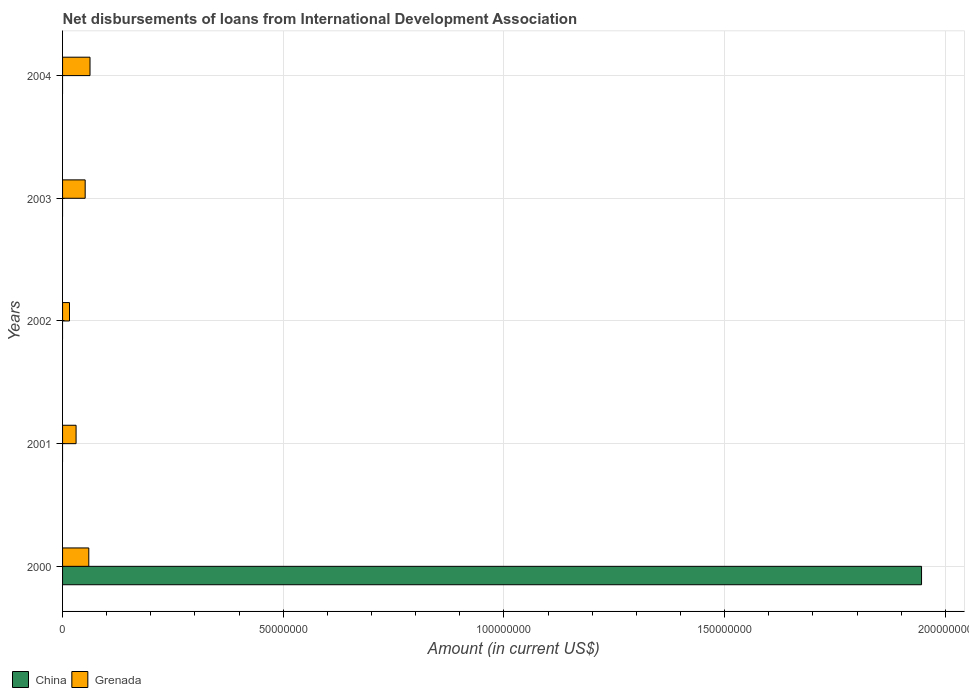Are the number of bars per tick equal to the number of legend labels?
Give a very brief answer. No. Are the number of bars on each tick of the Y-axis equal?
Ensure brevity in your answer.  No. How many bars are there on the 2nd tick from the bottom?
Make the answer very short. 1. What is the label of the 3rd group of bars from the top?
Give a very brief answer. 2002. What is the amount of loans disbursed in China in 2003?
Ensure brevity in your answer.  0. Across all years, what is the maximum amount of loans disbursed in China?
Offer a terse response. 1.95e+08. Across all years, what is the minimum amount of loans disbursed in China?
Give a very brief answer. 0. In which year was the amount of loans disbursed in China maximum?
Ensure brevity in your answer.  2000. What is the total amount of loans disbursed in Grenada in the graph?
Offer a very short reply. 2.19e+07. What is the difference between the amount of loans disbursed in Grenada in 2000 and that in 2002?
Your answer should be very brief. 4.37e+06. What is the difference between the amount of loans disbursed in China in 2000 and the amount of loans disbursed in Grenada in 2001?
Give a very brief answer. 1.92e+08. What is the average amount of loans disbursed in Grenada per year?
Provide a succinct answer. 4.38e+06. In the year 2000, what is the difference between the amount of loans disbursed in Grenada and amount of loans disbursed in China?
Provide a short and direct response. -1.89e+08. What is the ratio of the amount of loans disbursed in Grenada in 2001 to that in 2002?
Offer a very short reply. 1.95. What is the difference between the highest and the second highest amount of loans disbursed in Grenada?
Your response must be concise. 2.77e+05. What is the difference between the highest and the lowest amount of loans disbursed in Grenada?
Your response must be concise. 4.65e+06. In how many years, is the amount of loans disbursed in Grenada greater than the average amount of loans disbursed in Grenada taken over all years?
Make the answer very short. 3. Is the sum of the amount of loans disbursed in Grenada in 2000 and 2004 greater than the maximum amount of loans disbursed in China across all years?
Your answer should be very brief. No. How many bars are there?
Give a very brief answer. 6. What is the difference between two consecutive major ticks on the X-axis?
Provide a succinct answer. 5.00e+07. Does the graph contain any zero values?
Your answer should be compact. Yes. What is the title of the graph?
Your response must be concise. Net disbursements of loans from International Development Association. What is the label or title of the X-axis?
Provide a short and direct response. Amount (in current US$). What is the label or title of the Y-axis?
Your response must be concise. Years. What is the Amount (in current US$) of China in 2000?
Keep it short and to the point. 1.95e+08. What is the Amount (in current US$) in Grenada in 2000?
Provide a succinct answer. 5.94e+06. What is the Amount (in current US$) in Grenada in 2001?
Provide a succinct answer. 3.06e+06. What is the Amount (in current US$) of China in 2002?
Ensure brevity in your answer.  0. What is the Amount (in current US$) of Grenada in 2002?
Your answer should be very brief. 1.57e+06. What is the Amount (in current US$) in Grenada in 2003?
Offer a terse response. 5.12e+06. What is the Amount (in current US$) in China in 2004?
Provide a short and direct response. 0. What is the Amount (in current US$) of Grenada in 2004?
Provide a succinct answer. 6.22e+06. Across all years, what is the maximum Amount (in current US$) in China?
Provide a succinct answer. 1.95e+08. Across all years, what is the maximum Amount (in current US$) in Grenada?
Make the answer very short. 6.22e+06. Across all years, what is the minimum Amount (in current US$) of Grenada?
Keep it short and to the point. 1.57e+06. What is the total Amount (in current US$) of China in the graph?
Make the answer very short. 1.95e+08. What is the total Amount (in current US$) in Grenada in the graph?
Ensure brevity in your answer.  2.19e+07. What is the difference between the Amount (in current US$) of Grenada in 2000 and that in 2001?
Your answer should be very brief. 2.88e+06. What is the difference between the Amount (in current US$) in Grenada in 2000 and that in 2002?
Offer a terse response. 4.37e+06. What is the difference between the Amount (in current US$) of Grenada in 2000 and that in 2003?
Give a very brief answer. 8.20e+05. What is the difference between the Amount (in current US$) in Grenada in 2000 and that in 2004?
Give a very brief answer. -2.77e+05. What is the difference between the Amount (in current US$) in Grenada in 2001 and that in 2002?
Your answer should be compact. 1.49e+06. What is the difference between the Amount (in current US$) in Grenada in 2001 and that in 2003?
Make the answer very short. -2.06e+06. What is the difference between the Amount (in current US$) in Grenada in 2001 and that in 2004?
Your answer should be very brief. -3.16e+06. What is the difference between the Amount (in current US$) of Grenada in 2002 and that in 2003?
Give a very brief answer. -3.55e+06. What is the difference between the Amount (in current US$) of Grenada in 2002 and that in 2004?
Offer a terse response. -4.65e+06. What is the difference between the Amount (in current US$) in Grenada in 2003 and that in 2004?
Provide a succinct answer. -1.10e+06. What is the difference between the Amount (in current US$) in China in 2000 and the Amount (in current US$) in Grenada in 2001?
Your answer should be compact. 1.92e+08. What is the difference between the Amount (in current US$) of China in 2000 and the Amount (in current US$) of Grenada in 2002?
Provide a short and direct response. 1.93e+08. What is the difference between the Amount (in current US$) in China in 2000 and the Amount (in current US$) in Grenada in 2003?
Your answer should be compact. 1.89e+08. What is the difference between the Amount (in current US$) in China in 2000 and the Amount (in current US$) in Grenada in 2004?
Give a very brief answer. 1.88e+08. What is the average Amount (in current US$) of China per year?
Provide a succinct answer. 3.89e+07. What is the average Amount (in current US$) of Grenada per year?
Your response must be concise. 4.38e+06. In the year 2000, what is the difference between the Amount (in current US$) of China and Amount (in current US$) of Grenada?
Offer a very short reply. 1.89e+08. What is the ratio of the Amount (in current US$) in Grenada in 2000 to that in 2001?
Your response must be concise. 1.94. What is the ratio of the Amount (in current US$) of Grenada in 2000 to that in 2002?
Give a very brief answer. 3.78. What is the ratio of the Amount (in current US$) in Grenada in 2000 to that in 2003?
Offer a terse response. 1.16. What is the ratio of the Amount (in current US$) of Grenada in 2000 to that in 2004?
Provide a succinct answer. 0.96. What is the ratio of the Amount (in current US$) in Grenada in 2001 to that in 2002?
Offer a very short reply. 1.95. What is the ratio of the Amount (in current US$) of Grenada in 2001 to that in 2003?
Your answer should be very brief. 0.6. What is the ratio of the Amount (in current US$) of Grenada in 2001 to that in 2004?
Provide a succinct answer. 0.49. What is the ratio of the Amount (in current US$) in Grenada in 2002 to that in 2003?
Make the answer very short. 0.31. What is the ratio of the Amount (in current US$) in Grenada in 2002 to that in 2004?
Offer a terse response. 0.25. What is the ratio of the Amount (in current US$) in Grenada in 2003 to that in 2004?
Offer a very short reply. 0.82. What is the difference between the highest and the second highest Amount (in current US$) in Grenada?
Keep it short and to the point. 2.77e+05. What is the difference between the highest and the lowest Amount (in current US$) in China?
Your answer should be compact. 1.95e+08. What is the difference between the highest and the lowest Amount (in current US$) of Grenada?
Provide a succinct answer. 4.65e+06. 